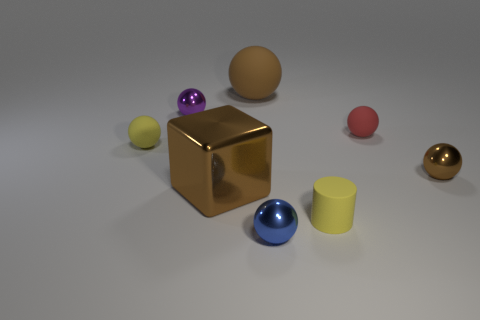Subtract all red spheres. How many spheres are left? 5 Subtract all small blue shiny spheres. How many spheres are left? 5 Subtract all cyan spheres. Subtract all yellow cylinders. How many spheres are left? 6 Add 2 purple metallic things. How many objects exist? 10 Subtract all cylinders. How many objects are left? 7 Subtract 1 yellow cylinders. How many objects are left? 7 Subtract all large shiny blocks. Subtract all large blocks. How many objects are left? 6 Add 5 brown balls. How many brown balls are left? 7 Add 3 cylinders. How many cylinders exist? 4 